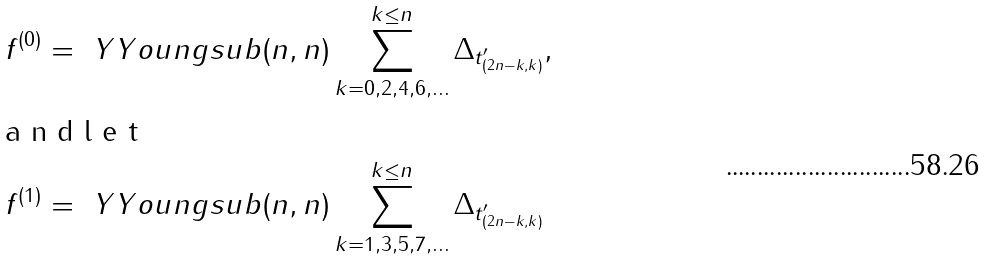Convert formula to latex. <formula><loc_0><loc_0><loc_500><loc_500>f ^ { ( 0 ) } & = \ Y Y o u n g s u b { ( n , n ) } \sum _ { k = 0 , 2 , 4 , 6 , \dots } ^ { k \leq n } \Delta _ { t ^ { \prime } _ { ( 2 n - k , k ) } } , \intertext { a n d l e t } f ^ { ( 1 ) } & = \ Y Y o u n g s u b { ( n , n ) } \sum _ { k = 1 , 3 , 5 , 7 , \dots } ^ { k \leq n } \Delta _ { t ^ { \prime } _ { ( 2 n - k , k ) } }</formula> 